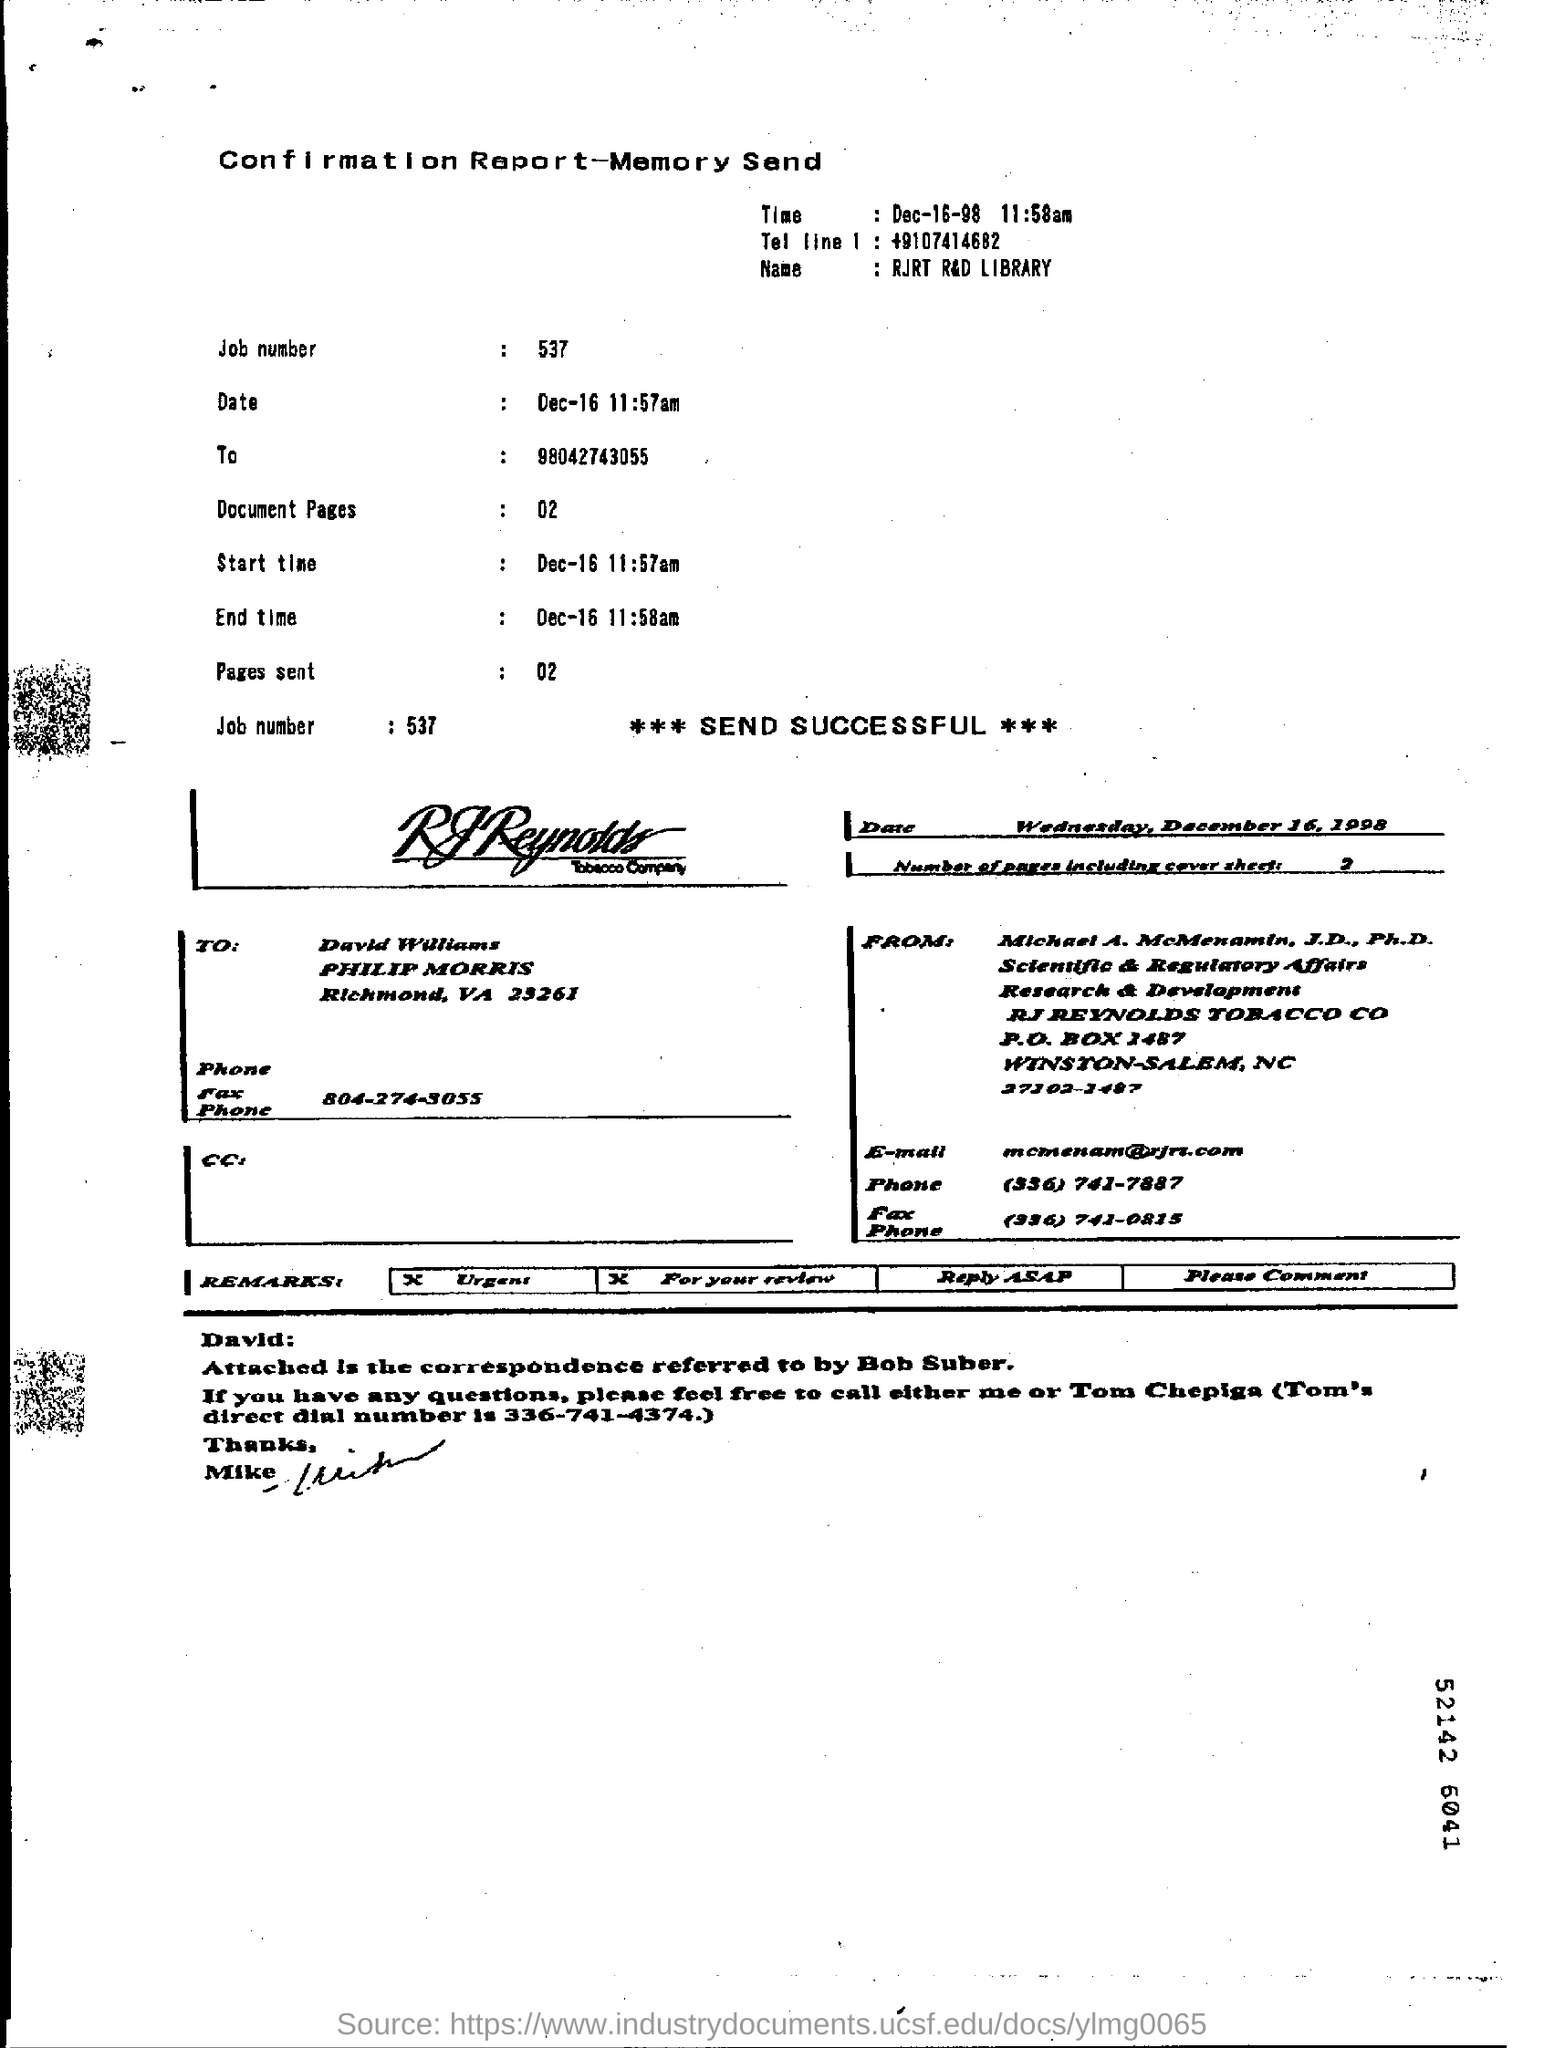Point out several critical features in this image. On December 16, 1998, it was a Wednesday. 